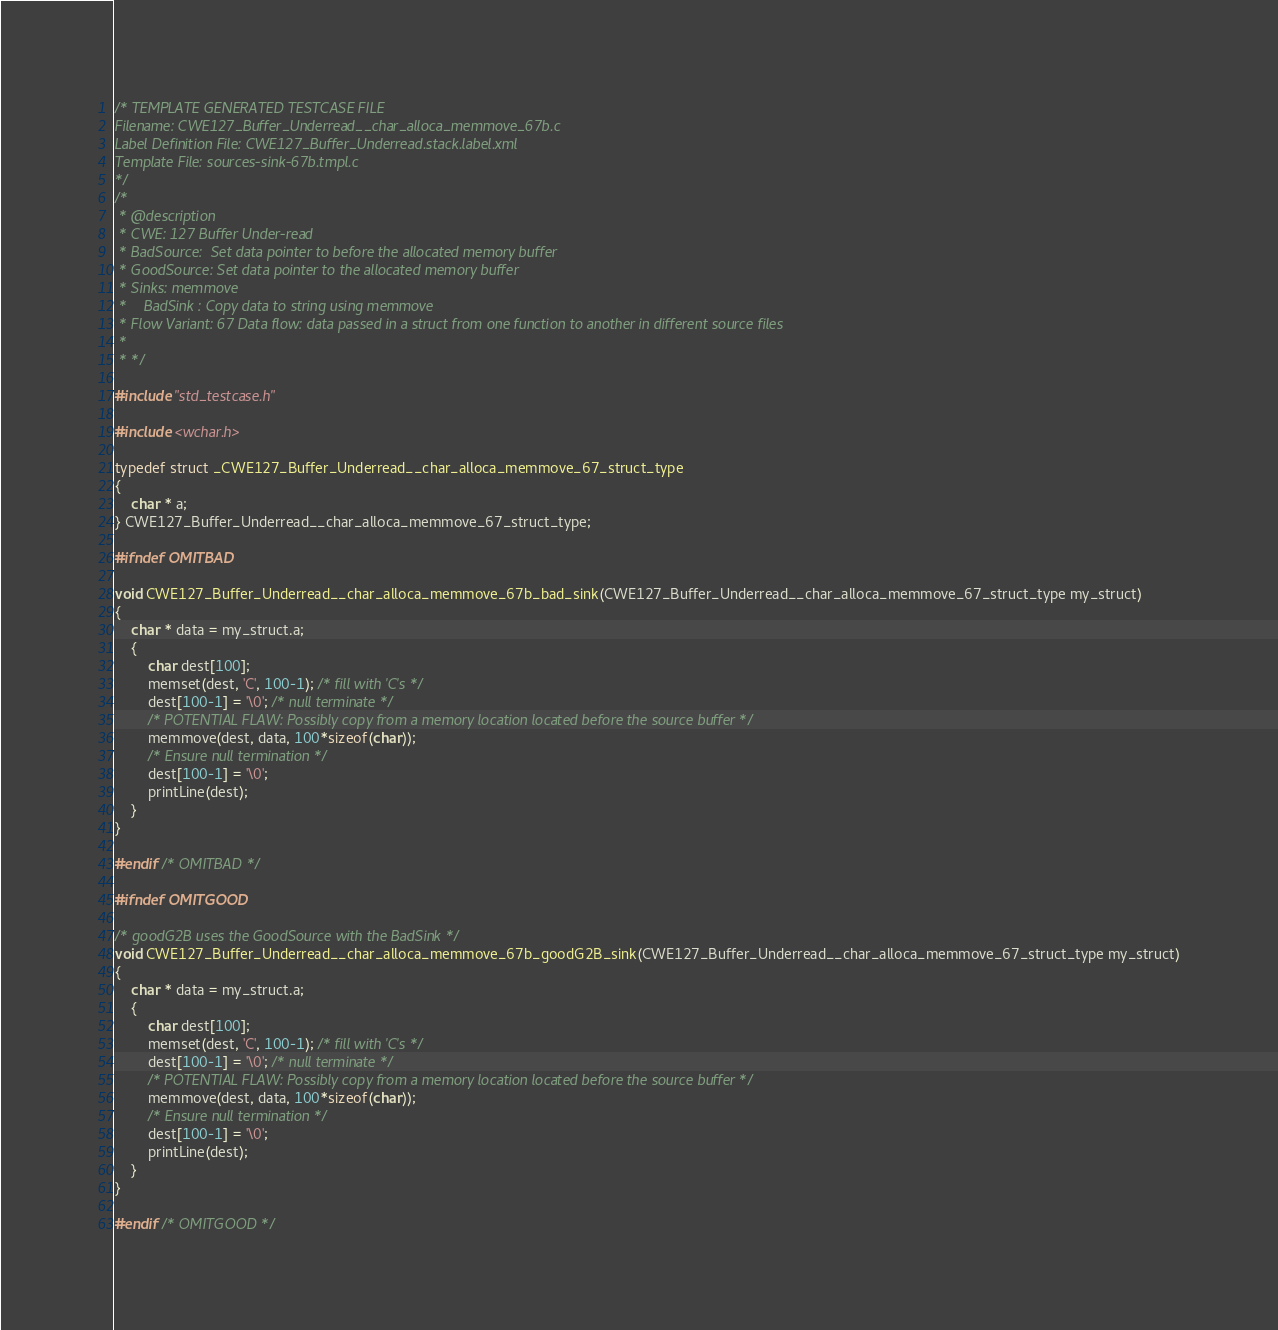Convert code to text. <code><loc_0><loc_0><loc_500><loc_500><_C_>/* TEMPLATE GENERATED TESTCASE FILE
Filename: CWE127_Buffer_Underread__char_alloca_memmove_67b.c
Label Definition File: CWE127_Buffer_Underread.stack.label.xml
Template File: sources-sink-67b.tmpl.c
*/
/*
 * @description
 * CWE: 127 Buffer Under-read
 * BadSource:  Set data pointer to before the allocated memory buffer
 * GoodSource: Set data pointer to the allocated memory buffer
 * Sinks: memmove
 *    BadSink : Copy data to string using memmove
 * Flow Variant: 67 Data flow: data passed in a struct from one function to another in different source files
 *
 * */

#include "std_testcase.h"

#include <wchar.h>

typedef struct _CWE127_Buffer_Underread__char_alloca_memmove_67_struct_type
{
    char * a;
} CWE127_Buffer_Underread__char_alloca_memmove_67_struct_type;

#ifndef OMITBAD

void CWE127_Buffer_Underread__char_alloca_memmove_67b_bad_sink(CWE127_Buffer_Underread__char_alloca_memmove_67_struct_type my_struct)
{
    char * data = my_struct.a;
    {
        char dest[100];
        memset(dest, 'C', 100-1); /* fill with 'C's */
        dest[100-1] = '\0'; /* null terminate */
        /* POTENTIAL FLAW: Possibly copy from a memory location located before the source buffer */
        memmove(dest, data, 100*sizeof(char));
        /* Ensure null termination */
        dest[100-1] = '\0';
        printLine(dest);
    }
}

#endif /* OMITBAD */

#ifndef OMITGOOD

/* goodG2B uses the GoodSource with the BadSink */
void CWE127_Buffer_Underread__char_alloca_memmove_67b_goodG2B_sink(CWE127_Buffer_Underread__char_alloca_memmove_67_struct_type my_struct)
{
    char * data = my_struct.a;
    {
        char dest[100];
        memset(dest, 'C', 100-1); /* fill with 'C's */
        dest[100-1] = '\0'; /* null terminate */
        /* POTENTIAL FLAW: Possibly copy from a memory location located before the source buffer */
        memmove(dest, data, 100*sizeof(char));
        /* Ensure null termination */
        dest[100-1] = '\0';
        printLine(dest);
    }
}

#endif /* OMITGOOD */
</code> 